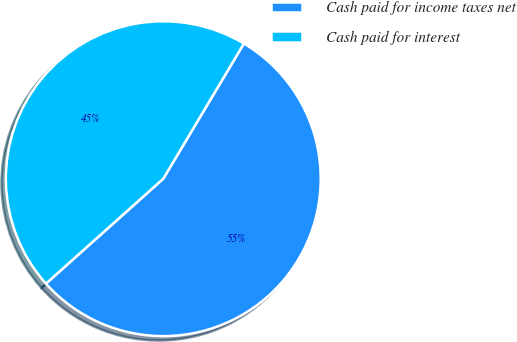Convert chart to OTSL. <chart><loc_0><loc_0><loc_500><loc_500><pie_chart><fcel>Cash paid for income taxes net<fcel>Cash paid for interest<nl><fcel>54.83%<fcel>45.17%<nl></chart> 